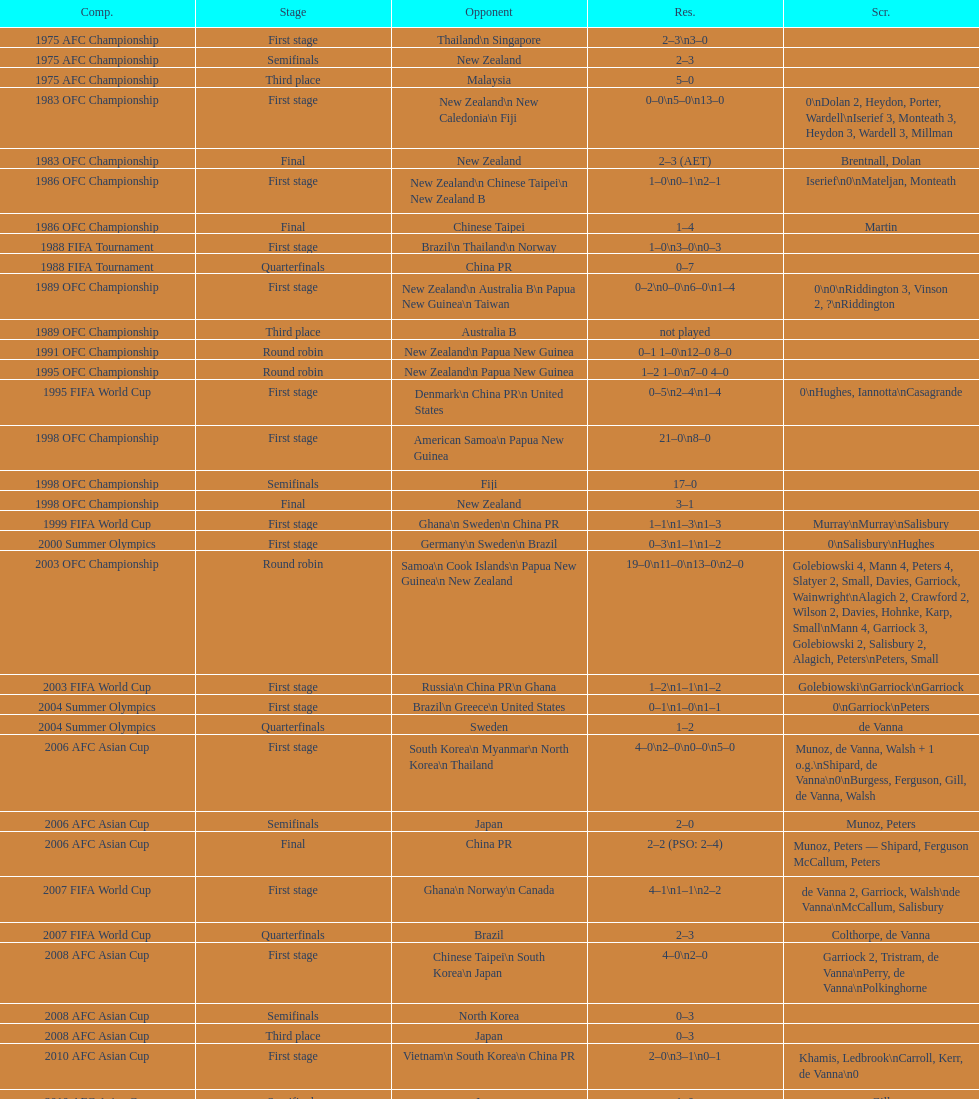How many points were scored in the final round of the 2012 summer olympics afc qualification? 12. 